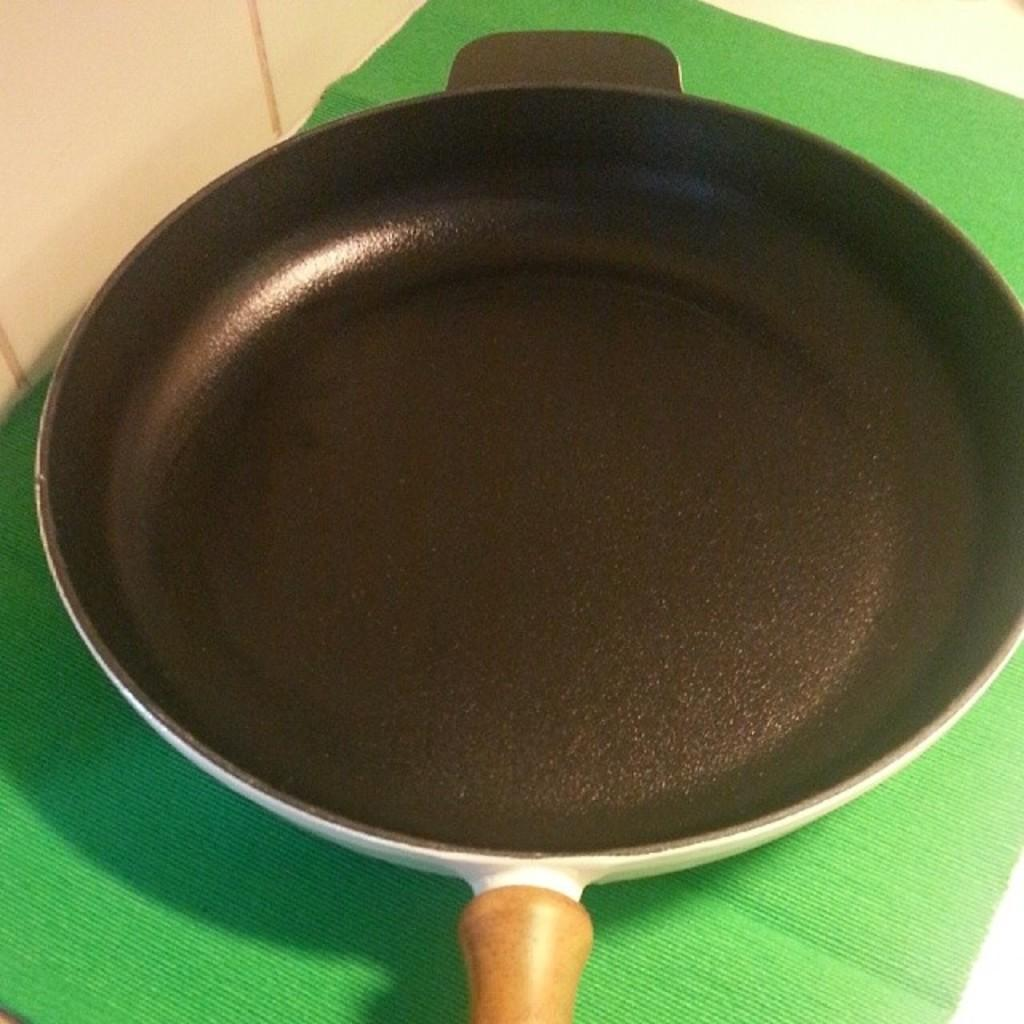What is the main object in the image? There is a black pan in the image. Where is the black pan placed? The black pan is placed on a green mat. What can be seen on the left side of the image? There is a cream-colored wall on the left side of the image. What type of plot does the society in the image revolve around? There is no society or plot present in the image; it features a black pan placed on a green mat with a cream-colored wall on the left side. 